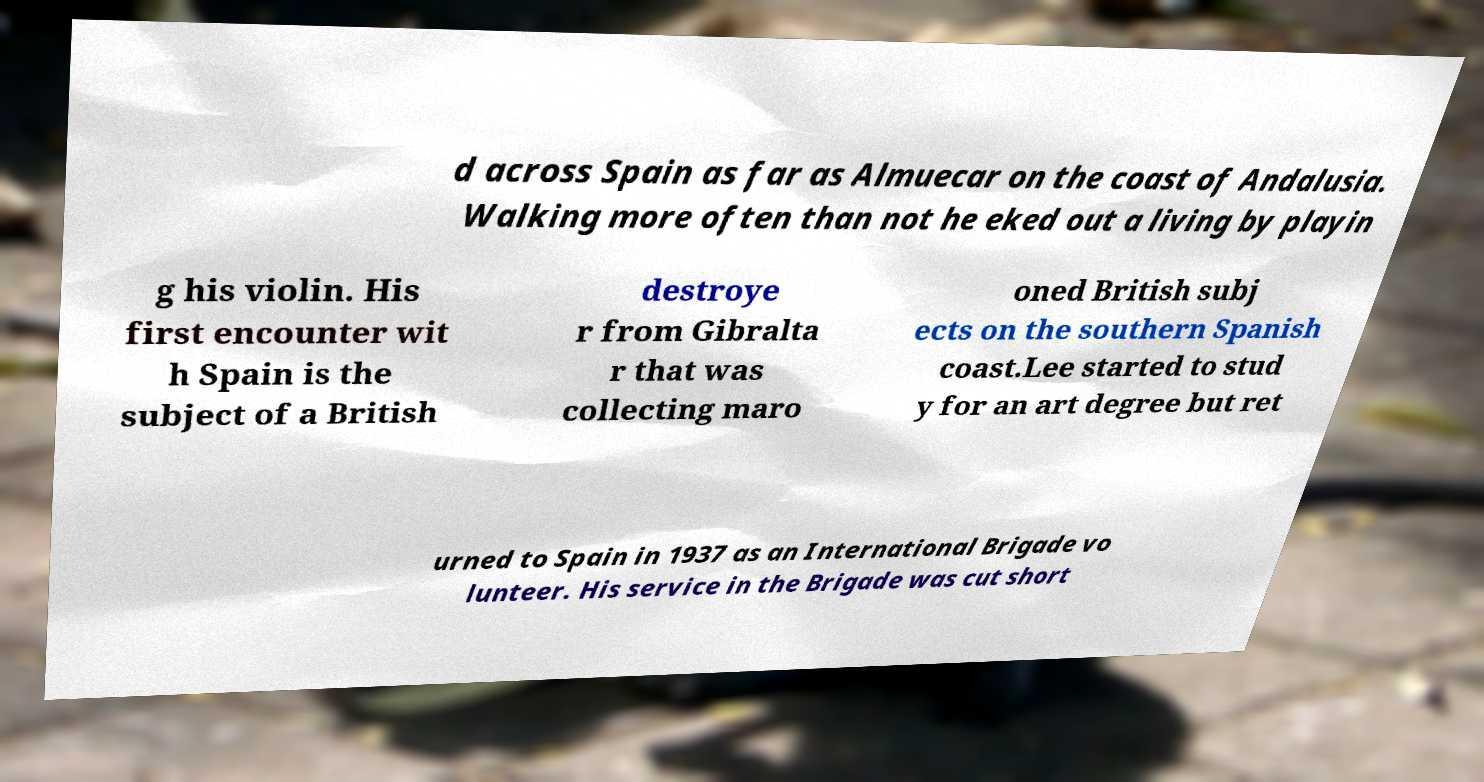Can you accurately transcribe the text from the provided image for me? d across Spain as far as Almuecar on the coast of Andalusia. Walking more often than not he eked out a living by playin g his violin. His first encounter wit h Spain is the subject of a British destroye r from Gibralta r that was collecting maro oned British subj ects on the southern Spanish coast.Lee started to stud y for an art degree but ret urned to Spain in 1937 as an International Brigade vo lunteer. His service in the Brigade was cut short 